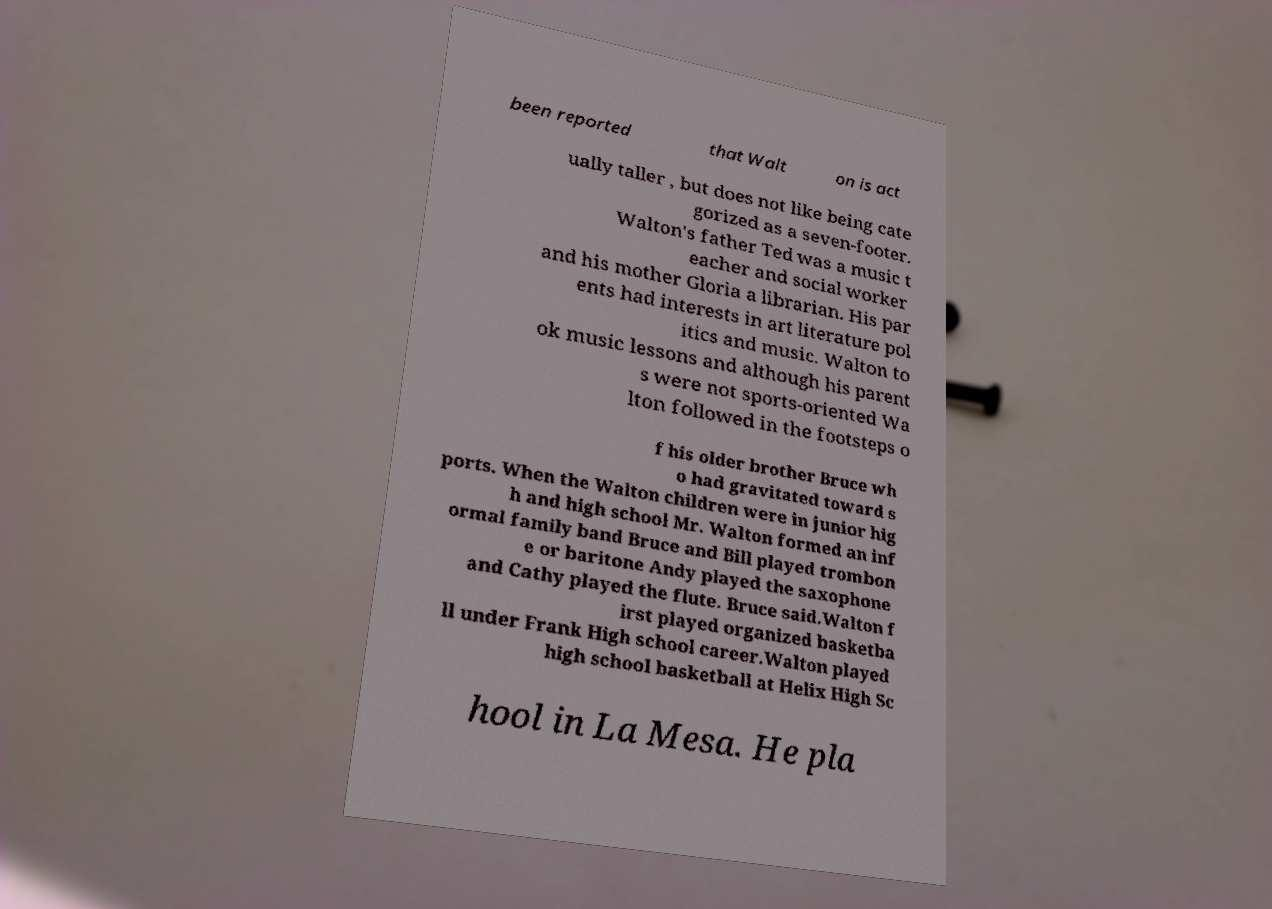Could you extract and type out the text from this image? been reported that Walt on is act ually taller , but does not like being cate gorized as a seven-footer. Walton's father Ted was a music t eacher and social worker and his mother Gloria a librarian. His par ents had interests in art literature pol itics and music. Walton to ok music lessons and although his parent s were not sports-oriented Wa lton followed in the footsteps o f his older brother Bruce wh o had gravitated toward s ports. When the Walton children were in junior hig h and high school Mr. Walton formed an inf ormal family band Bruce and Bill played trombon e or baritone Andy played the saxophone and Cathy played the flute. Bruce said.Walton f irst played organized basketba ll under Frank High school career.Walton played high school basketball at Helix High Sc hool in La Mesa. He pla 